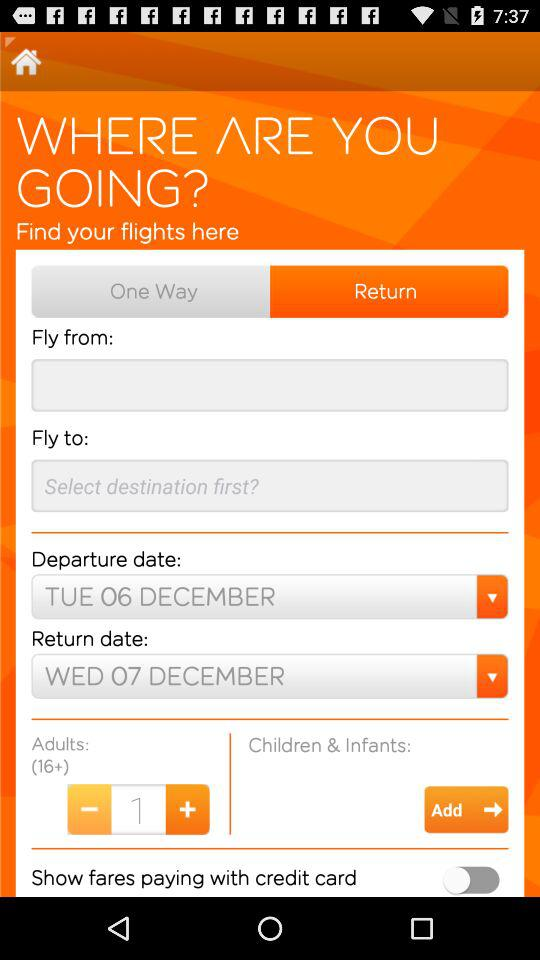What is the departure date? The departure date is Tuesday, December 6. 